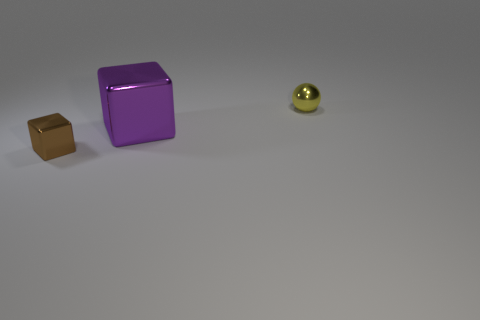There is a object on the right side of the purple object; is its size the same as the large object?
Provide a succinct answer. No. The small metal thing to the right of the small shiny object that is in front of the metallic sphere is what color?
Make the answer very short. Yellow. Are there any other things that are the same size as the purple shiny block?
Give a very brief answer. No. Does the metal object that is in front of the purple block have the same shape as the yellow thing?
Offer a terse response. No. What number of shiny cubes are to the left of the large purple shiny thing and behind the brown metallic block?
Ensure brevity in your answer.  0. The metal block to the left of the metal block on the right side of the object in front of the big purple shiny cube is what color?
Your answer should be compact. Brown. There is a object behind the big purple cube; how many large purple things are on the left side of it?
Provide a short and direct response. 1. How many other objects are the same shape as the small yellow thing?
Your answer should be compact. 0. How many things are small matte objects or small metal objects that are in front of the small yellow thing?
Provide a short and direct response. 1. Are there more shiny objects that are in front of the big shiny cube than yellow metal objects to the left of the shiny ball?
Keep it short and to the point. Yes. 